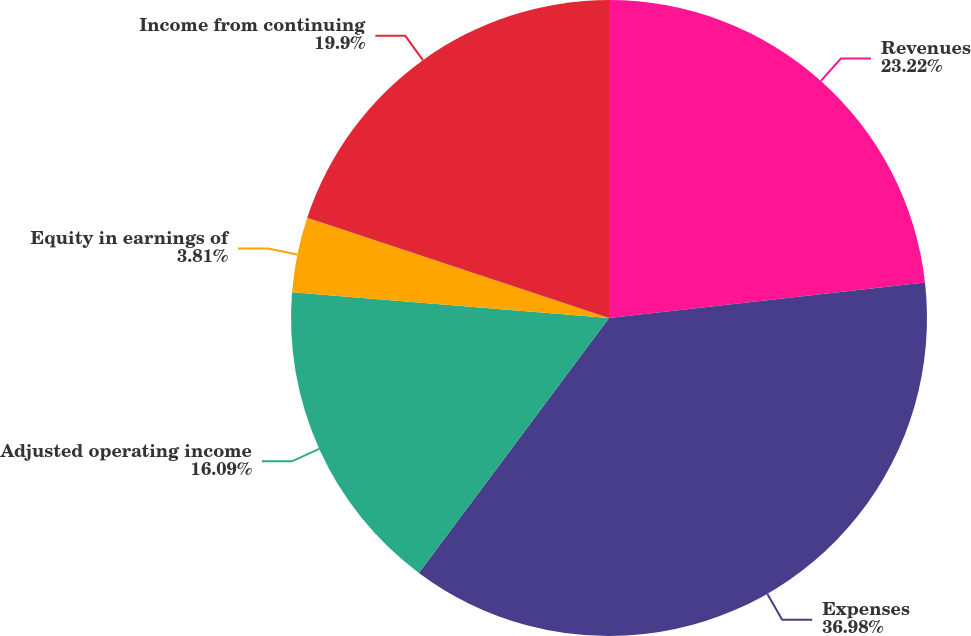<chart> <loc_0><loc_0><loc_500><loc_500><pie_chart><fcel>Revenues<fcel>Expenses<fcel>Adjusted operating income<fcel>Equity in earnings of<fcel>Income from continuing<nl><fcel>23.22%<fcel>36.98%<fcel>16.09%<fcel>3.81%<fcel>19.9%<nl></chart> 